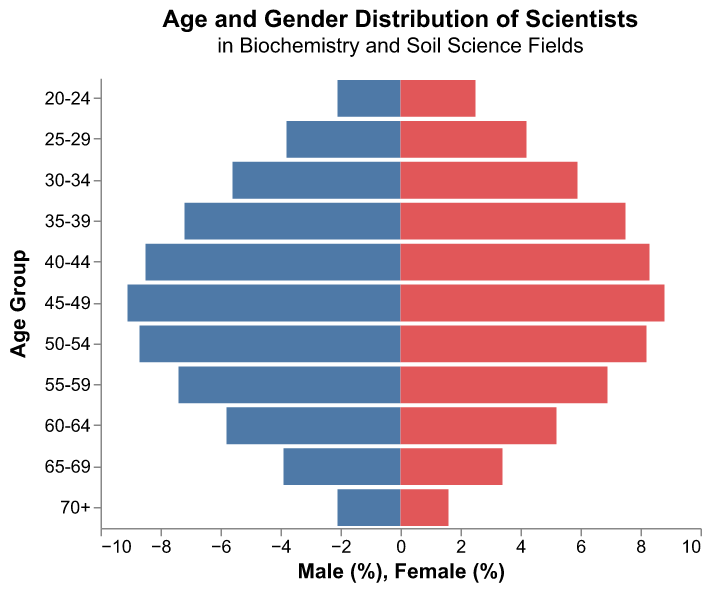What is the age range with the highest percentage of male scientists? The percentage values for each age range are observed to determine which range has the highest value for males. The range with 9.1% is the highest.
Answer: 45-49 What is the total percentage of female scientists in the 40-44 and 45-49 age groups? Sum the percentage values of females in the 40-44 (8.3%) and 45-49 (8.8%) age groups: 8.3 + 8.8 = 17.1%.
Answer: 17.1% Which age group has a higher percentage of female scientists compared to male scientists, 55-59 or 60-64? Compare the values for the 55-59 age group (7.4% male, 6.9% female) and the 60-64 age group (5.8% male, 5.2% female). In neither age group do females exceed the percentage of males.
Answer: Neither What is the difference in percentage between male and female scientists in the 70+ age group? Subtract the female percentage from the male percentage in the 70+ age group: 2.1% - 1.6% = 0.5%.
Answer: 0.5% How does the percentage of scientists in their 30s (30-34 and 35-39 combined) compare between males and females? sum the percentages for the 30-34 (5.6% male, 5.9% female) and 35-39 (7.2% male, 7.5% female) groups: for males, 5.6 + 7.2 = 12.8%; for females, 5.9 + 7.5 = 13.4%.
Answer: 12.8% males, 13.4% females What is the percentage difference between male and female scientists aged 20-24? Subtract the male percentage from the female percentage: 2.5% - 2.1% = 0.4%.
Answer: 0.4% Which age group has the most balanced gender distribution? Calculate the absolute differences between male and female percentages for each age group, and find the smallest one. The smallest difference is for the 40-44 age group (8.5% male, 8.3% female; difference = 0.2%).
Answer: 40-44 What is the trend in the percentage of male scientists from ages 20-24 to 70+? Observe the male percentage values, noting that they generally increase from 20-24 (2.1%) to 45-49 (9.1%), then decrease from 50-54 (8.7%) to 70+ (2.1%).
Answer: Increasing then decreasing 